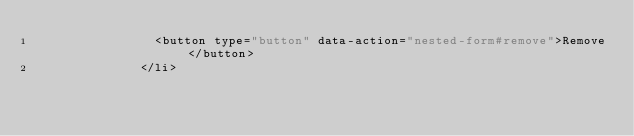Convert code to text. <code><loc_0><loc_0><loc_500><loc_500><_JavaScript_>                <button type="button" data-action="nested-form#remove">Remove</button>
              </li></code> 